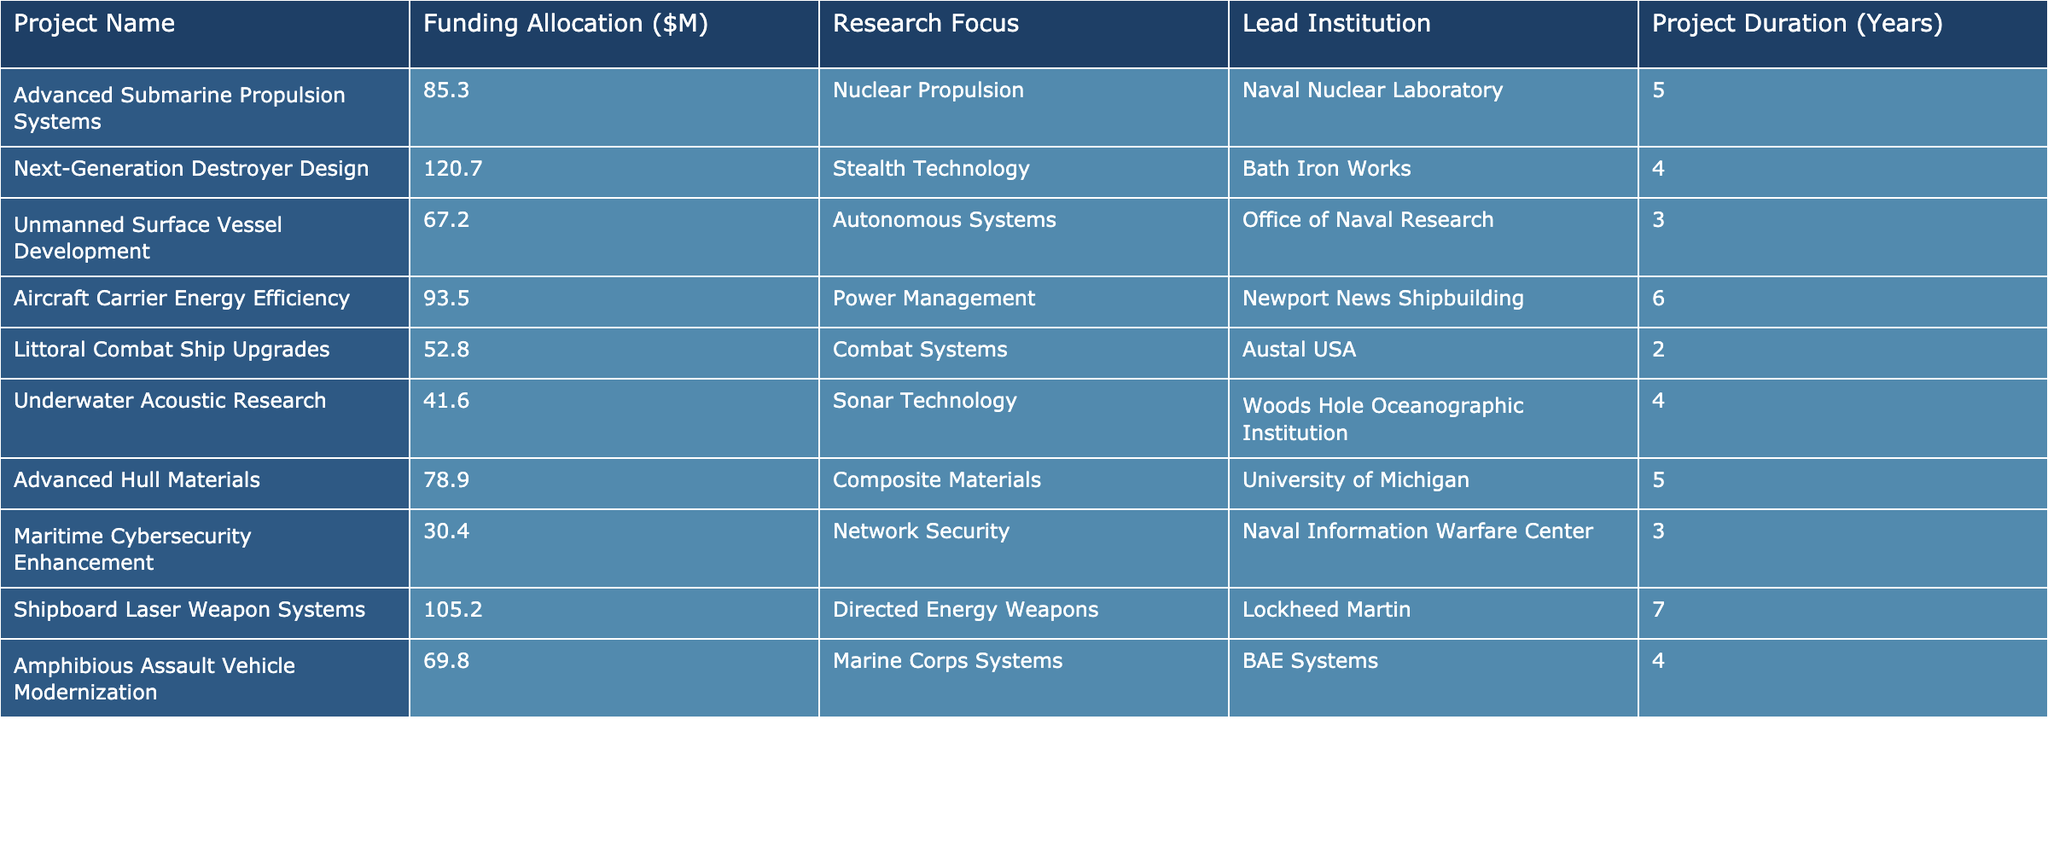What is the funding allocation for the project titled 'Next-Generation Destroyer Design'? The table shows the specific funding allocation listed under the 'Funding Allocation ($M)' column for the project 'Next-Generation Destroyer Design'. The corresponding value is 120.7 million dollars.
Answer: 120.7 Which project has the highest funding allocation? By comparing the values in the 'Funding Allocation ($M)' column, 'Shipboard Laser Weapon Systems' has the highest allocation at 105.2 million dollars.
Answer: Shipboard Laser Weapon Systems What is the average funding allocation for projects focused on 'Autonomous Systems'? The only project listed under 'Autonomous Systems' is 'Unmanned Surface Vessel Development' with a funding allocation of 67.2 million dollars. Thus, the average is simply the amount itself because there's only one project.
Answer: 67.2 Is the project 'Maritime Cybersecurity Enhancement' allocated more than 40 million dollars? The funding allocation for 'Maritime Cybersecurity Enhancement' is listed as 30.4 million dollars, which is less than 40 million dollars. Thus, the answer is no.
Answer: No How much funding is allocated to projects with a duration of 4 years? The projects with a duration of 4 years are 'Next-Generation Destroyer Design' (120.7 million), 'Underwater Acoustic Research' (41.6 million), and 'Amphibious Assault Vehicle Modernization' (69.8 million). Summing these amounts gives 120.7 + 41.6 + 69.8 = 232.1 million dollars.
Answer: 232.1 Which institution has the most projects listed in this table? By examining the 'Lead Institution' column, we see that 'BAE Systems' is associated with 'Amphibious Assault Vehicle Modernization', and 'Lockheed Martin' with 'Shipboard Laser Weapon Systems'; every other institution leads only one project each. Thus, there is no clear institution with multiple projects.
Answer: None What percentage of the total funding is allocated to 'Nuclear Propulsion' projects? There is one project in the 'Nuclear Propulsion' category with a funding allocation of 85.3 million dollars. The total funding across all projects is 85.3 + 120.7 + 67.2 + 93.5 + 52.8 + 41.6 + 78.9 + 30.4 + 105.2 + 69.8 = 785.6 million dollars. Therefore, the percentage allocated to 'Nuclear Propulsion' is (85.3 / 785.6) * 100 = 10.87%.
Answer: 10.87% Which project has the longest duration, and how long is it? The table indicates that the project 'Shipboard Laser Weapon Systems' has a duration of 7 years, which is the longest compared to others.
Answer: Shipboard Laser Weapon Systems, 7 years Is 'Aircraft Carrier Energy Efficiency' the only project focusing on 'Power Management'? By reviewing the 'Research Focus' column, it is clear that 'Aircraft Carrier Energy Efficiency' is the only project that lists 'Power Management' as its focus. Therefore, the answer is yes.
Answer: Yes How does the funding for 'Advanced Hull Materials' compare to the average funding of all projects? The funding for 'Advanced Hull Materials' is 78.9 million dollars. The average funding across all projects is calculated as 785.6 million divided by 10, which equals 78.56 million dollars. Since 78.9 million is greater than 78.56 million, 'Advanced Hull Materials' has more funding than the average.
Answer: More than average 